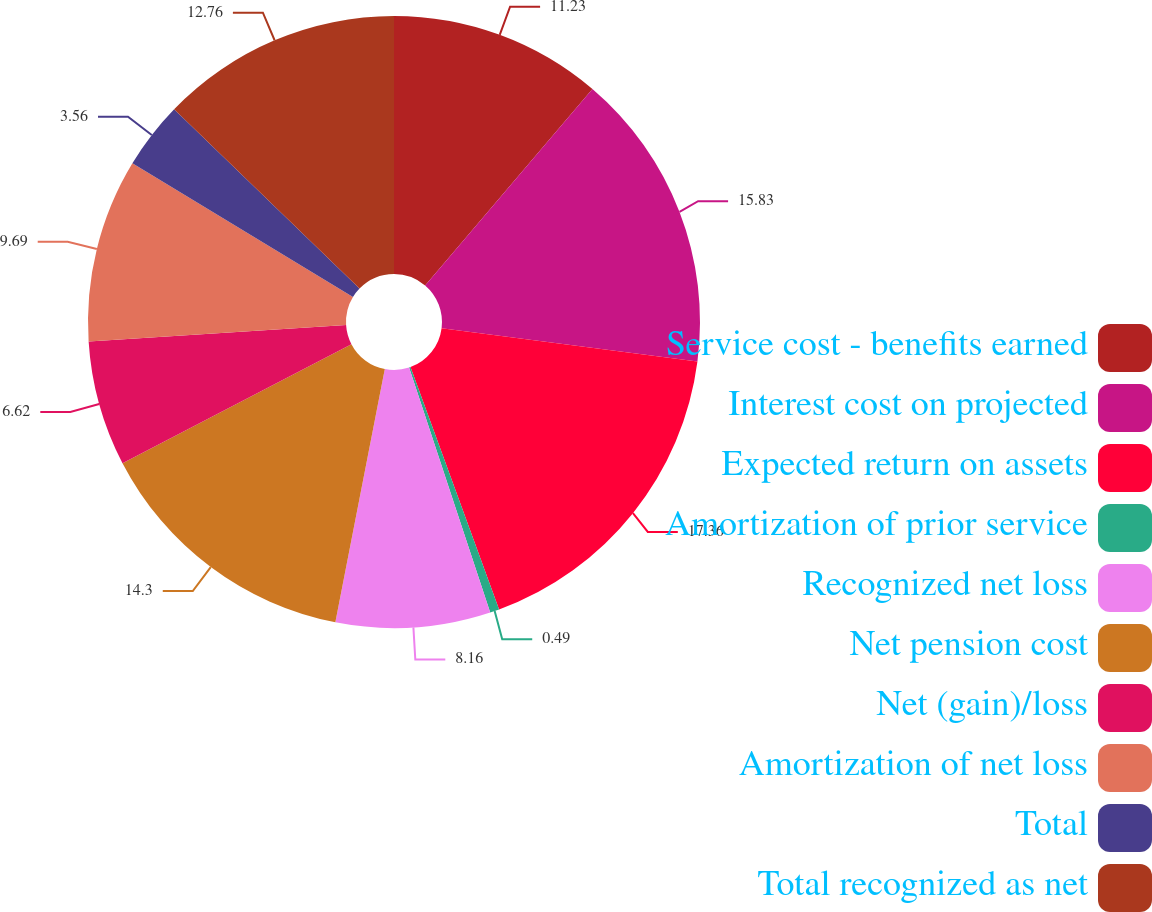Convert chart to OTSL. <chart><loc_0><loc_0><loc_500><loc_500><pie_chart><fcel>Service cost - benefits earned<fcel>Interest cost on projected<fcel>Expected return on assets<fcel>Amortization of prior service<fcel>Recognized net loss<fcel>Net pension cost<fcel>Net (gain)/loss<fcel>Amortization of net loss<fcel>Total<fcel>Total recognized as net<nl><fcel>11.23%<fcel>15.83%<fcel>17.36%<fcel>0.49%<fcel>8.16%<fcel>14.3%<fcel>6.62%<fcel>9.69%<fcel>3.56%<fcel>12.76%<nl></chart> 